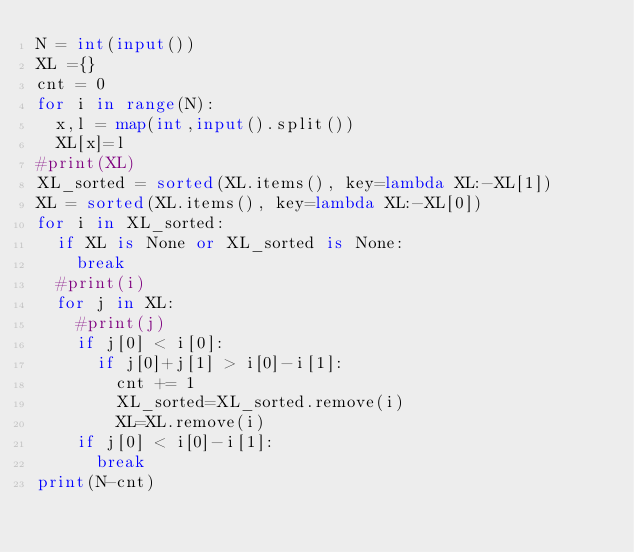<code> <loc_0><loc_0><loc_500><loc_500><_Python_>N = int(input())
XL ={}
cnt = 0
for i in range(N):
  x,l = map(int,input().split())
  XL[x]=l
#print(XL)
XL_sorted = sorted(XL.items(), key=lambda XL:-XL[1])
XL = sorted(XL.items(), key=lambda XL:-XL[0])
for i in XL_sorted:
  if XL is None or XL_sorted is None:
    break
  #print(i)
  for j in XL:
    #print(j)
    if j[0] < i[0]:
      if j[0]+j[1] > i[0]-i[1]:
        cnt += 1
        XL_sorted=XL_sorted.remove(i)
        XL=XL.remove(i)
    if j[0] < i[0]-i[1]:
      break
print(N-cnt)</code> 